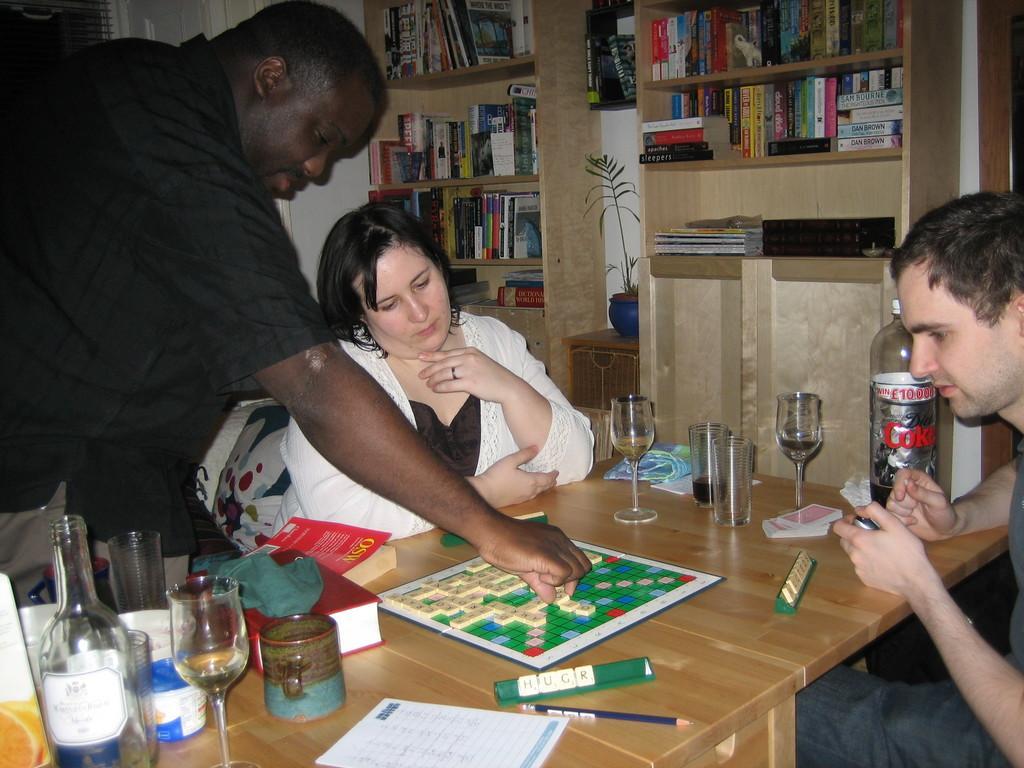How would you summarize this image in a sentence or two? In this image there are three person. The woman is sitting. On the table there are glass,bottle,book,cloth,board,paper,pencil and cards. There is a book rack and a flower pot. 